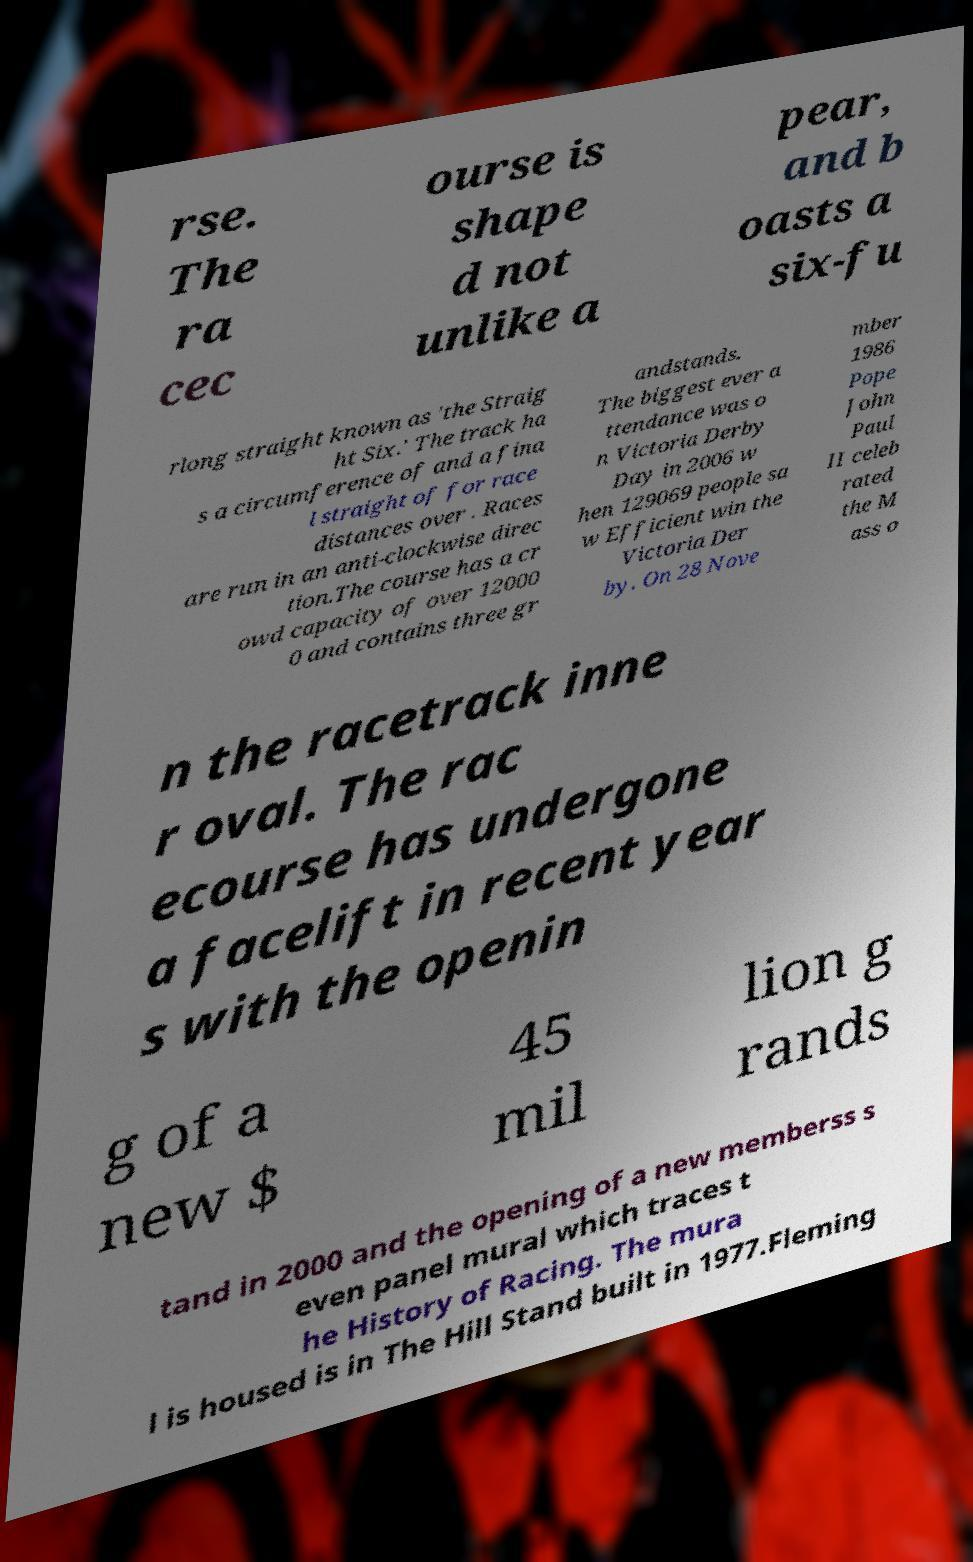What messages or text are displayed in this image? I need them in a readable, typed format. rse. The ra cec ourse is shape d not unlike a pear, and b oasts a six-fu rlong straight known as 'the Straig ht Six.' The track ha s a circumference of and a fina l straight of for race distances over . Races are run in an anti-clockwise direc tion.The course has a cr owd capacity of over 12000 0 and contains three gr andstands. The biggest ever a ttendance was o n Victoria Derby Day in 2006 w hen 129069 people sa w Efficient win the Victoria Der by. On 28 Nove mber 1986 Pope John Paul II celeb rated the M ass o n the racetrack inne r oval. The rac ecourse has undergone a facelift in recent year s with the openin g of a new $ 45 mil lion g rands tand in 2000 and the opening of a new memberss s even panel mural which traces t he History of Racing. The mura l is housed is in The Hill Stand built in 1977.Fleming 